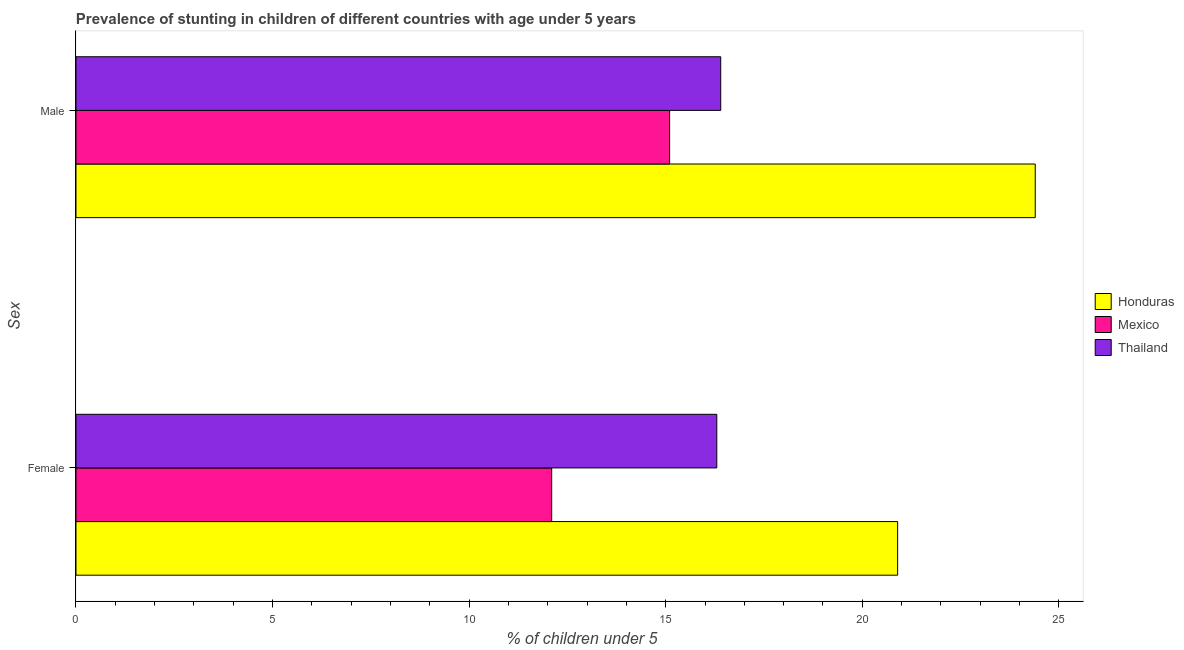How many groups of bars are there?
Offer a terse response. 2. Are the number of bars per tick equal to the number of legend labels?
Provide a short and direct response. Yes. Are the number of bars on each tick of the Y-axis equal?
Offer a very short reply. Yes. How many bars are there on the 2nd tick from the top?
Your response must be concise. 3. What is the label of the 1st group of bars from the top?
Your answer should be compact. Male. What is the percentage of stunted female children in Mexico?
Give a very brief answer. 12.1. Across all countries, what is the maximum percentage of stunted male children?
Provide a succinct answer. 24.4. Across all countries, what is the minimum percentage of stunted female children?
Keep it short and to the point. 12.1. In which country was the percentage of stunted male children maximum?
Your response must be concise. Honduras. What is the total percentage of stunted male children in the graph?
Your answer should be compact. 55.9. What is the difference between the percentage of stunted male children in Thailand and that in Mexico?
Provide a short and direct response. 1.3. What is the difference between the percentage of stunted female children in Mexico and the percentage of stunted male children in Thailand?
Give a very brief answer. -4.3. What is the average percentage of stunted female children per country?
Your answer should be compact. 16.43. What is the difference between the percentage of stunted male children and percentage of stunted female children in Thailand?
Make the answer very short. 0.1. In how many countries, is the percentage of stunted female children greater than 22 %?
Your response must be concise. 0. What is the ratio of the percentage of stunted male children in Mexico to that in Thailand?
Offer a very short reply. 0.92. Is the percentage of stunted female children in Thailand less than that in Honduras?
Offer a terse response. Yes. In how many countries, is the percentage of stunted male children greater than the average percentage of stunted male children taken over all countries?
Provide a succinct answer. 1. What does the 1st bar from the top in Male represents?
Provide a short and direct response. Thailand. What does the 1st bar from the bottom in Male represents?
Offer a terse response. Honduras. How many bars are there?
Your answer should be very brief. 6. Are all the bars in the graph horizontal?
Give a very brief answer. Yes. Are the values on the major ticks of X-axis written in scientific E-notation?
Your response must be concise. No. Does the graph contain grids?
Ensure brevity in your answer.  No. How many legend labels are there?
Your answer should be very brief. 3. What is the title of the graph?
Provide a succinct answer. Prevalence of stunting in children of different countries with age under 5 years. Does "Ecuador" appear as one of the legend labels in the graph?
Provide a short and direct response. No. What is the label or title of the X-axis?
Ensure brevity in your answer.   % of children under 5. What is the label or title of the Y-axis?
Offer a terse response. Sex. What is the  % of children under 5 of Honduras in Female?
Your answer should be compact. 20.9. What is the  % of children under 5 of Mexico in Female?
Provide a succinct answer. 12.1. What is the  % of children under 5 in Thailand in Female?
Offer a very short reply. 16.3. What is the  % of children under 5 in Honduras in Male?
Make the answer very short. 24.4. What is the  % of children under 5 in Mexico in Male?
Your answer should be very brief. 15.1. What is the  % of children under 5 of Thailand in Male?
Give a very brief answer. 16.4. Across all Sex, what is the maximum  % of children under 5 in Honduras?
Make the answer very short. 24.4. Across all Sex, what is the maximum  % of children under 5 of Mexico?
Make the answer very short. 15.1. Across all Sex, what is the maximum  % of children under 5 of Thailand?
Keep it short and to the point. 16.4. Across all Sex, what is the minimum  % of children under 5 of Honduras?
Your answer should be very brief. 20.9. Across all Sex, what is the minimum  % of children under 5 of Mexico?
Offer a very short reply. 12.1. Across all Sex, what is the minimum  % of children under 5 of Thailand?
Ensure brevity in your answer.  16.3. What is the total  % of children under 5 in Honduras in the graph?
Offer a very short reply. 45.3. What is the total  % of children under 5 of Mexico in the graph?
Ensure brevity in your answer.  27.2. What is the total  % of children under 5 of Thailand in the graph?
Your response must be concise. 32.7. What is the difference between the  % of children under 5 of Honduras in Female and that in Male?
Make the answer very short. -3.5. What is the difference between the  % of children under 5 in Mexico in Female and that in Male?
Give a very brief answer. -3. What is the difference between the  % of children under 5 in Thailand in Female and that in Male?
Your answer should be very brief. -0.1. What is the difference between the  % of children under 5 of Honduras in Female and the  % of children under 5 of Thailand in Male?
Offer a terse response. 4.5. What is the average  % of children under 5 in Honduras per Sex?
Offer a terse response. 22.65. What is the average  % of children under 5 of Mexico per Sex?
Ensure brevity in your answer.  13.6. What is the average  % of children under 5 of Thailand per Sex?
Ensure brevity in your answer.  16.35. What is the difference between the  % of children under 5 of Mexico and  % of children under 5 of Thailand in Female?
Ensure brevity in your answer.  -4.2. What is the ratio of the  % of children under 5 in Honduras in Female to that in Male?
Ensure brevity in your answer.  0.86. What is the ratio of the  % of children under 5 in Mexico in Female to that in Male?
Ensure brevity in your answer.  0.8. What is the difference between the highest and the second highest  % of children under 5 of Thailand?
Make the answer very short. 0.1. What is the difference between the highest and the lowest  % of children under 5 of Thailand?
Your response must be concise. 0.1. 